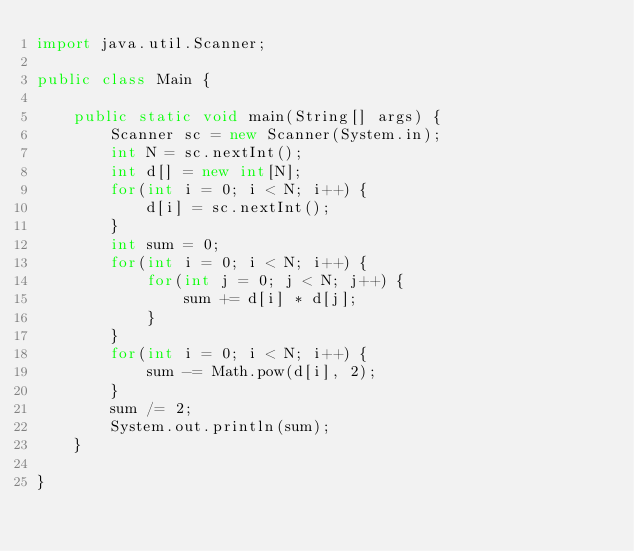<code> <loc_0><loc_0><loc_500><loc_500><_Java_>import java.util.Scanner;

public class Main {

	public static void main(String[] args) {
		Scanner sc = new Scanner(System.in);
		int N = sc.nextInt();
		int d[] = new int[N];
		for(int i = 0; i < N; i++) { 
			d[i] = sc.nextInt();
		}
		int sum = 0;
		for(int i = 0; i < N; i++) {
			for(int j = 0; j < N; j++) {
				sum += d[i] * d[j];
			}
		}
		for(int i = 0; i < N; i++) {
			sum -= Math.pow(d[i], 2);
		}
		sum /= 2;
		System.out.println(sum);
	}

}
</code> 